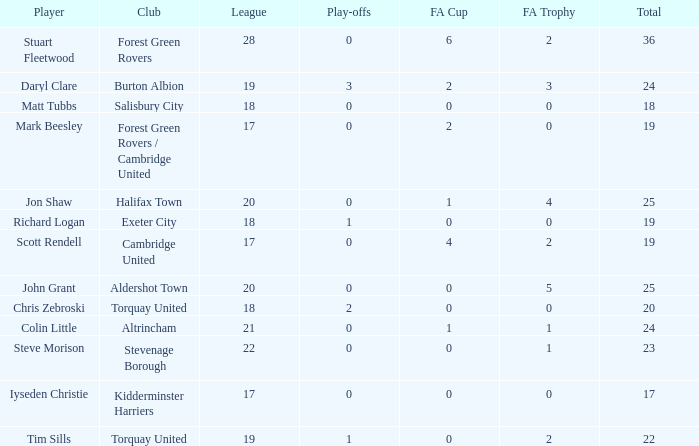Which of the lowest leagues had Aldershot town as a club when the play-offs number was less than 0? None. 